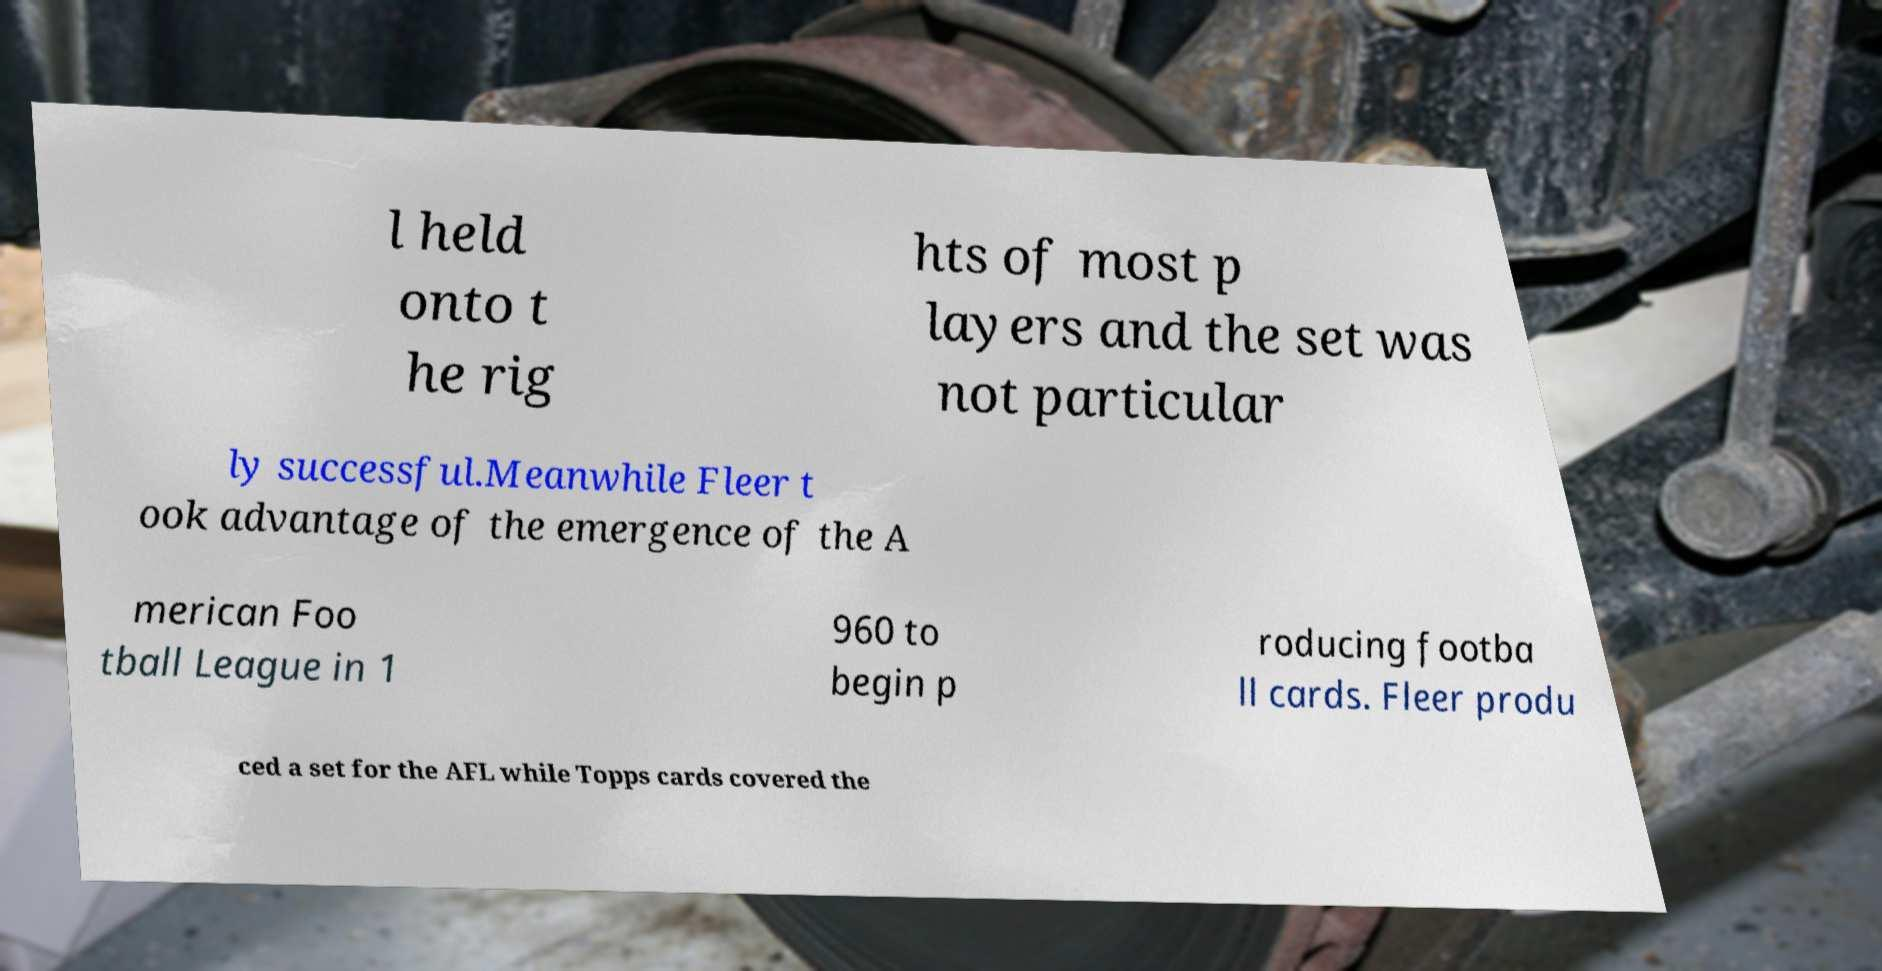I need the written content from this picture converted into text. Can you do that? l held onto t he rig hts of most p layers and the set was not particular ly successful.Meanwhile Fleer t ook advantage of the emergence of the A merican Foo tball League in 1 960 to begin p roducing footba ll cards. Fleer produ ced a set for the AFL while Topps cards covered the 